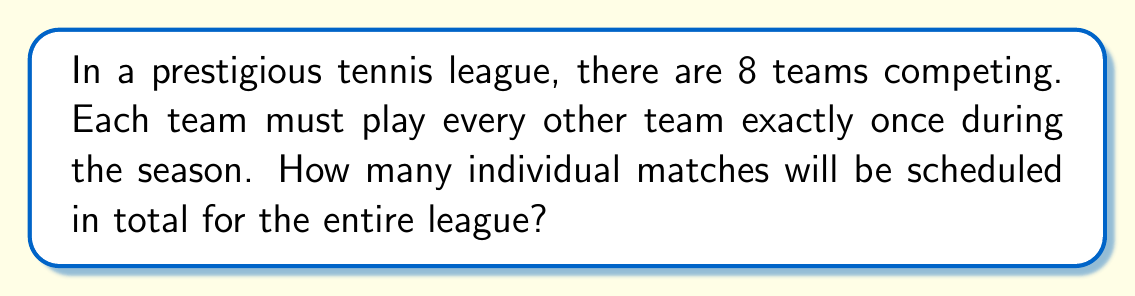Could you help me with this problem? Let's approach this step-by-step:

1) First, we need to understand that this is a combination problem. We're looking for the number of ways to choose 2 teams from 8 teams (as each match involves 2 teams).

2) The formula for this combination is:

   $$\binom{n}{r} = \frac{n!}{r!(n-r)!}$$

   Where $n$ is the total number of teams and $r$ is the number of teams playing in each match.

3) In this case, $n = 8$ (total teams) and $r = 2$ (teams per match).

4) Plugging these values into our formula:

   $$\binom{8}{2} = \frac{8!}{2!(8-2)!} = \frac{8!}{2!(6)!}$$

5) Let's calculate this:
   
   $$\frac{8 \cdot 7 \cdot 6!}{2 \cdot 1 \cdot 6!} = \frac{56}{2} = 28$$

6) Therefore, there will be 28 individual matches scheduled in the league.

This method ensures that each team plays every other team exactly once, which is a common format in round-robin tennis tournaments.
Answer: 28 matches 